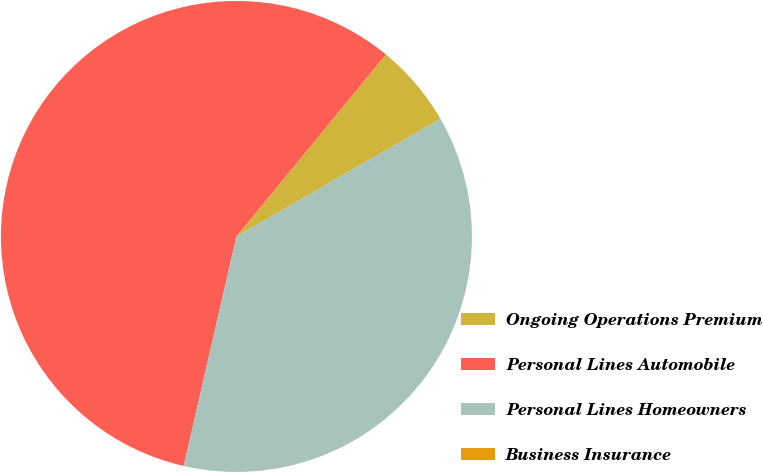Convert chart to OTSL. <chart><loc_0><loc_0><loc_500><loc_500><pie_chart><fcel>Ongoing Operations Premium<fcel>Personal Lines Automobile<fcel>Personal Lines Homeowners<fcel>Business Insurance<nl><fcel>5.73%<fcel>57.35%<fcel>36.92%<fcel>0.0%<nl></chart> 